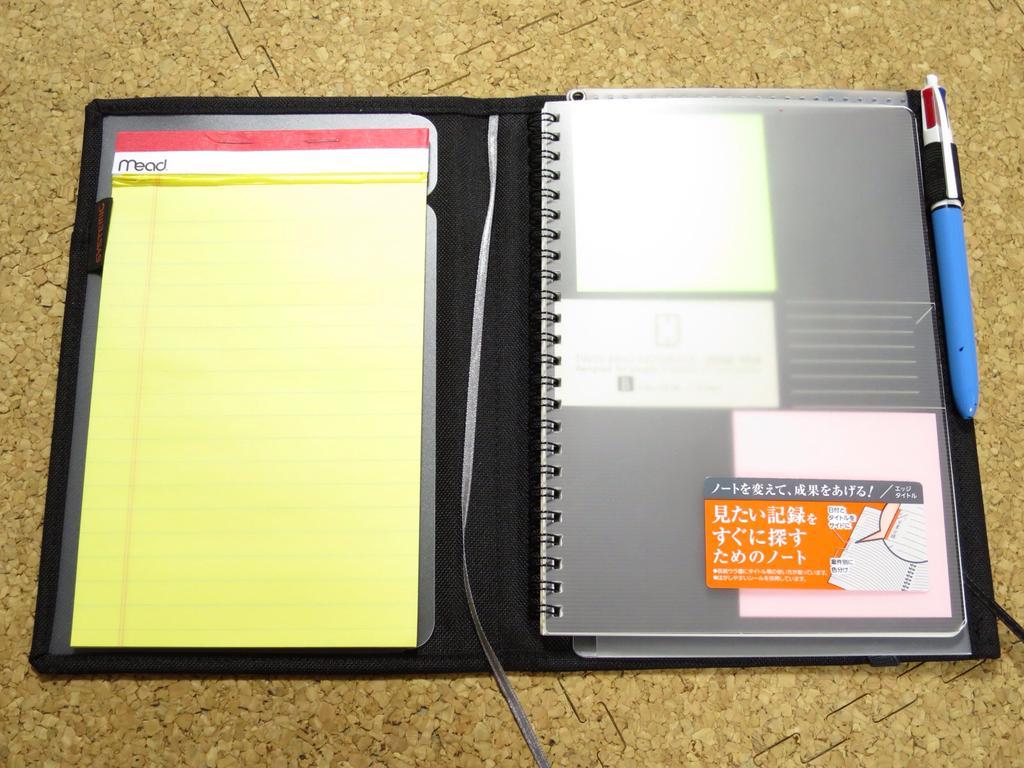Describe this image in one or two sentences. In this picture we can see a diary and a pen on the platform. 